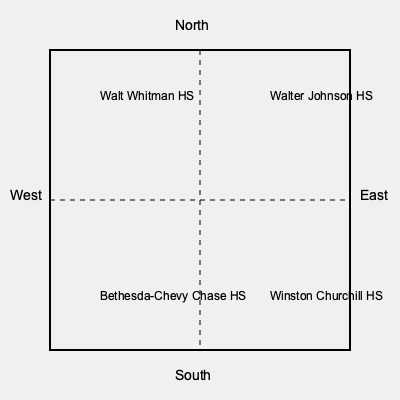Based on the map of Bethesda, MD school districts, which high school would a student living in the southeast quadrant of the city most likely attend? To determine the correct high school for a student living in the southeast quadrant of Bethesda, MD, we need to follow these steps:

1. Identify the quadrants of the map:
   - The map is divided into four quadrants by dashed lines.
   - The northern half is above the horizontal dashed line.
   - The southern half is below the horizontal dashed line.
   - The western half is to the left of the vertical dashed line.
   - The eastern half is to the right of the vertical dashed line.

2. Locate the southeast quadrant:
   - The southeast quadrant is in the lower right corner of the map.
   - It is below the horizontal dashed line (south) and to the right of the vertical dashed line (east).

3. Identify the high school in the southeast quadrant:
   - Each quadrant contains the name of a high school.
   - In the southeast quadrant, we can see "Winston Churchill HS".

Therefore, a student living in the southeast quadrant of Bethesda, MD would most likely attend Winston Churchill High School.
Answer: Winston Churchill High School 